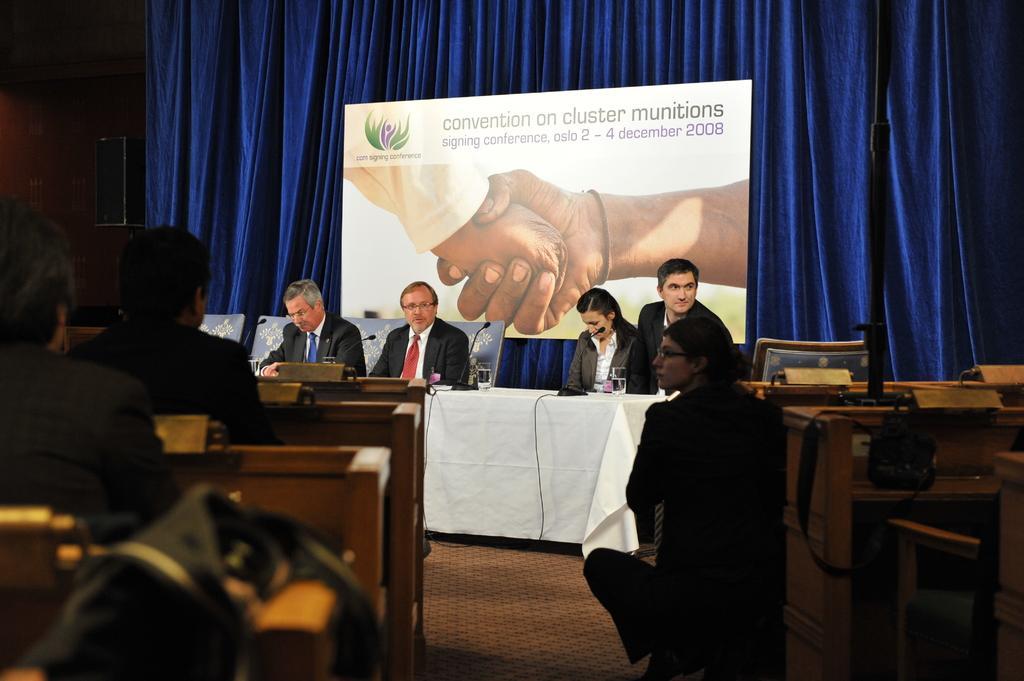Could you give a brief overview of what you see in this image? In this picture we can see person sitting on chair and in front of them there is table and on table we have glass, mic stands and here some crowd of people are watching them and in background we can see screen with some motivational message and curtain in blue color and here we have speaker. 